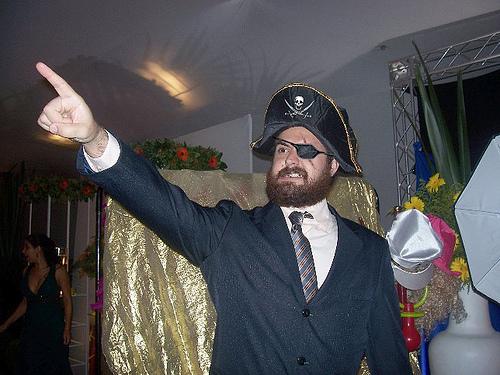Which eye is the eye patch covering?
Quick response, please. Left. What is the man doing with his right hand?
Short answer required. Pointing. What is this man dressed as?
Quick response, please. Pirate. 